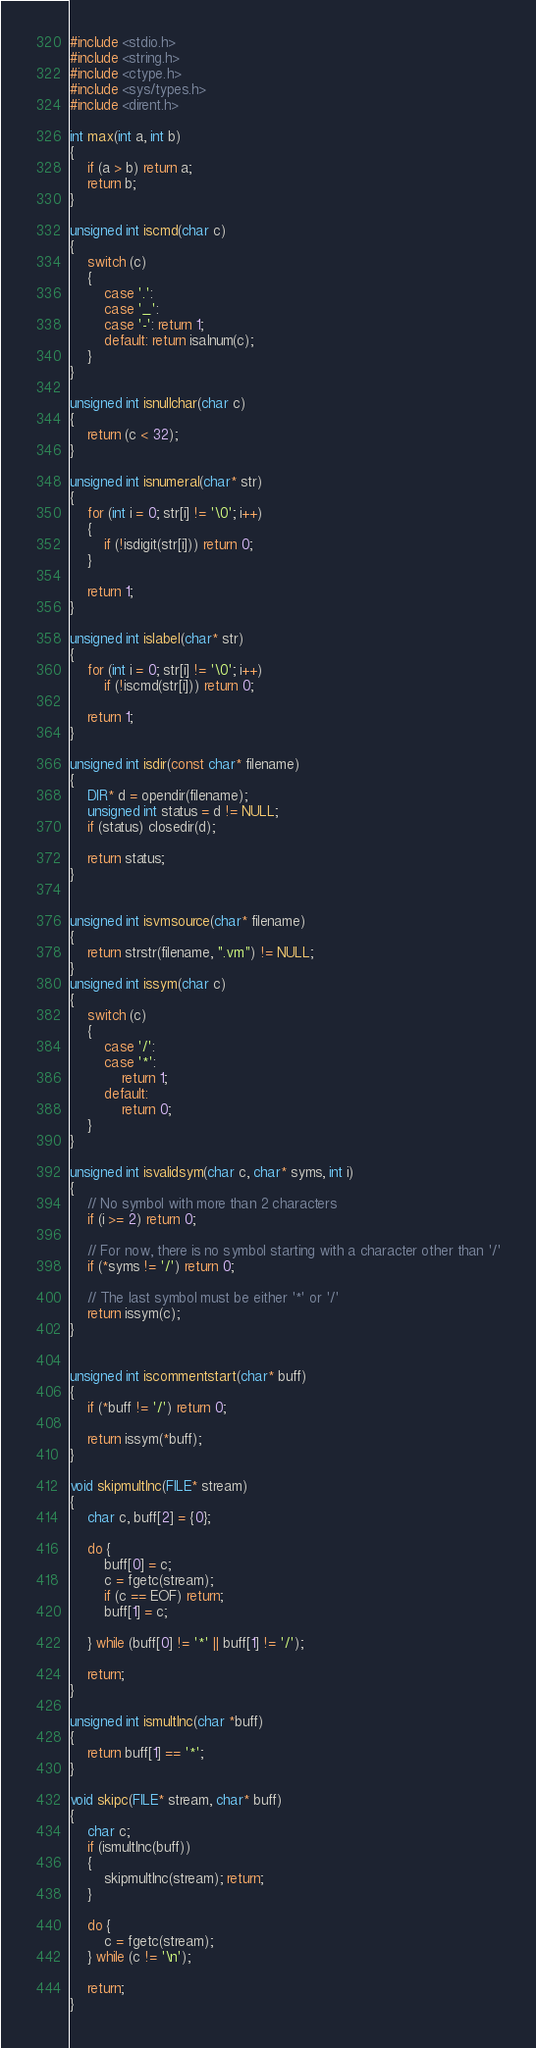Convert code to text. <code><loc_0><loc_0><loc_500><loc_500><_C_>#include <stdio.h>
#include <string.h>
#include <ctype.h>
#include <sys/types.h>
#include <dirent.h>

int max(int a, int b)
{
    if (a > b) return a;
    return b;
}

unsigned int iscmd(char c)
{
    switch (c)
    {
        case '.':
        case '_': 
        case '-': return 1;
        default: return isalnum(c);
    }
}

unsigned int isnullchar(char c)
{
    return (c < 32);
}

unsigned int isnumeral(char* str)
{
    for (int i = 0; str[i] != '\0'; i++)
    {
        if (!isdigit(str[i])) return 0;
    }

    return 1; 
}

unsigned int islabel(char* str)
{
    for (int i = 0; str[i] != '\0'; i++)
        if (!iscmd(str[i])) return 0;
    
    return 1; 
}

unsigned int isdir(const char* filename)
{
    DIR* d = opendir(filename);
    unsigned int status = d != NULL;
    if (status) closedir(d);

    return status;
}


unsigned int isvmsource(char* filename)
{
    return strstr(filename, ".vm") != NULL;
}
unsigned int issym(char c)
{
    switch (c)
    {
        case '/':
        case '*': 
            return 1; 
        default: 
            return 0;
    }
}

unsigned int isvalidsym(char c, char* syms, int i)
{
    // No symbol with more than 2 characters
    if (i >= 2) return 0; 

    // For now, there is no symbol starting with a character other than '/'
    if (*syms != '/') return 0;

    // The last symbol must be either '*' or '/'
    return issym(c);
}


unsigned int iscommentstart(char* buff)
{
    if (*buff != '/') return 0; 

    return issym(*buff);
}

void skipmultlnc(FILE* stream)
{
    char c, buff[2] = {0};

    do {
        buff[0] = c;
        c = fgetc(stream);
        if (c == EOF) return;
        buff[1] = c;
        
    } while (buff[0] != '*' || buff[1] != '/'); 
    
    return;
}

unsigned int ismultlnc(char *buff)
{
    return buff[1] == '*';
}

void skipc(FILE* stream, char* buff)
{
    char c;
    if (ismultlnc(buff)) 
    {
        skipmultlnc(stream); return; 
    }

    do {
        c = fgetc(stream);
    } while (c != '\n');
    
    return;
}








</code> 